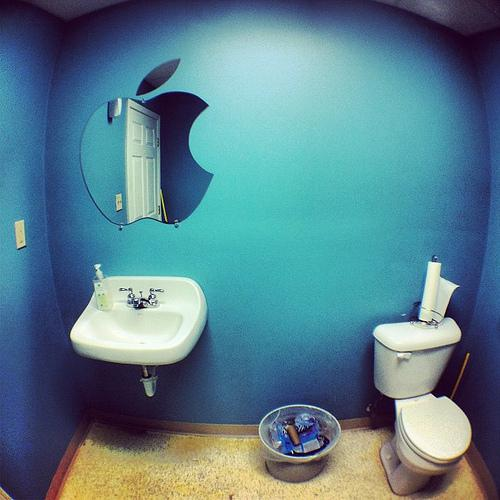Question: what shape is the mirror?
Choices:
A. Heart.
B. Triangle.
C. Apple.
D. Square.
Answer with the letter. Answer: C Question: where is the trashcan?
Choices:
A. Between the sink and toilet.
B. On the ground.
C. On the wall.
D. In the wall.
Answer with the letter. Answer: A Question: how many people are in the photo?
Choices:
A. 2.
B. 3.
C. 4.
D. None.
Answer with the letter. Answer: D Question: where is the toilet?
Choices:
A. In the bathroom.
B. In the water.
C. In the trash.
D. On the right of the photo.
Answer with the letter. Answer: D Question: where is the plunger?
Choices:
A. Near the sink.
B. Behind the toilet.
C. Near the vanity.
D. Near the closet.
Answer with the letter. Answer: B Question: what color is the bathroom?
Choices:
A. Red.
B. Green.
C. Blue.
D. White.
Answer with the letter. Answer: C 